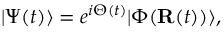Convert formula to latex. <formula><loc_0><loc_0><loc_500><loc_500>| \Psi ( t ) \rangle = e ^ { i \Theta ( t ) } | \Phi ( { R } ( t ) ) \rangle ,</formula> 